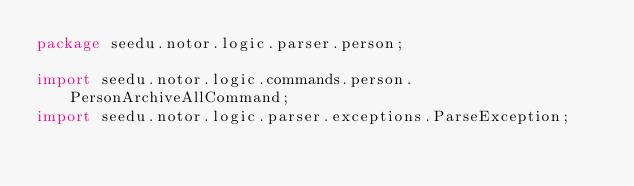<code> <loc_0><loc_0><loc_500><loc_500><_Java_>package seedu.notor.logic.parser.person;

import seedu.notor.logic.commands.person.PersonArchiveAllCommand;
import seedu.notor.logic.parser.exceptions.ParseException;
</code> 